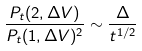<formula> <loc_0><loc_0><loc_500><loc_500>\frac { P _ { t } ( 2 , \Delta V ) } { P _ { t } ( 1 , \Delta V ) ^ { 2 } } \sim \frac { \Delta } { t ^ { 1 / 2 } }</formula> 